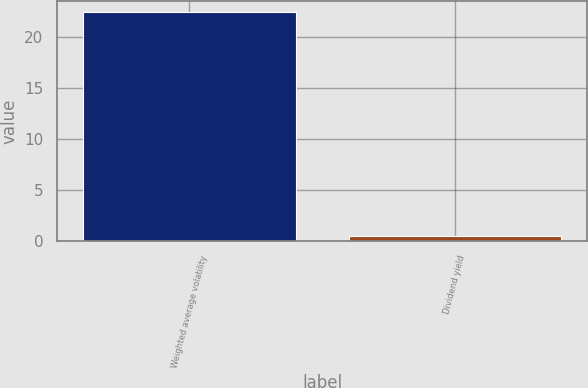Convert chart. <chart><loc_0><loc_0><loc_500><loc_500><bar_chart><fcel>Weighted average volatility<fcel>Dividend yield<nl><fcel>22.4<fcel>0.5<nl></chart> 